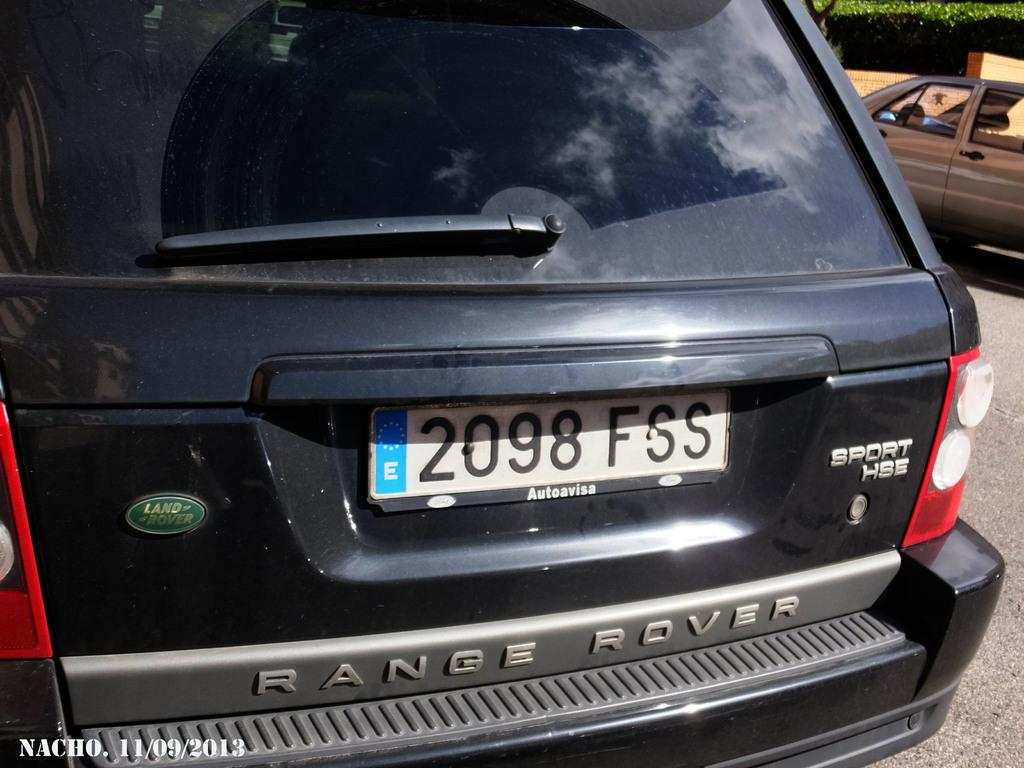Provide a one-sentence caption for the provided image. The black car shown is a range rover made by land rover. 